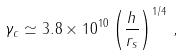<formula> <loc_0><loc_0><loc_500><loc_500>\gamma _ { c } \simeq 3 . 8 \times 1 0 ^ { 1 0 } \left ( \frac { h } { r _ { s } } \right ) ^ { 1 / 4 } \, ,</formula> 